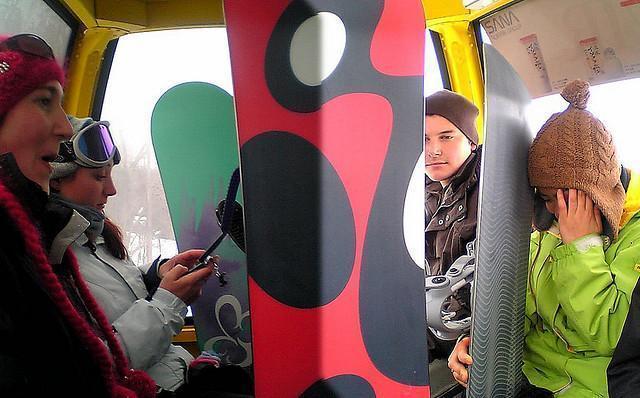What winter sport is this group participating in?
Make your selection from the four choices given to correctly answer the question.
Options: Snowboarding, skiing, sledding, ice skating. Snowboarding. 